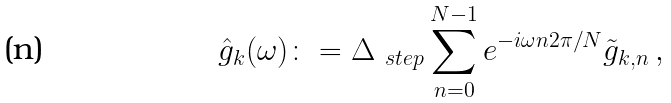Convert formula to latex. <formula><loc_0><loc_0><loc_500><loc_500>\hat { g } _ { k } ( \omega ) \colon = \Delta _ { \ s t e p } \sum _ { n = 0 } ^ { N - 1 } e ^ { - i \omega n 2 \pi / N } \tilde { g } _ { k , n } \, ,</formula> 